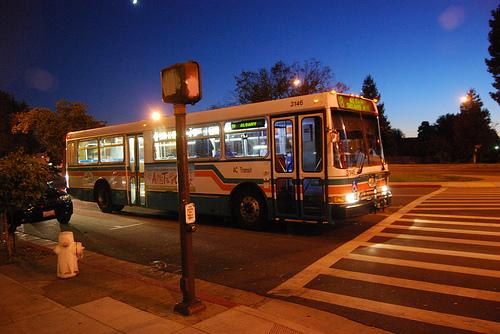Provide a brief summary of the key objects in the image and their interconnections. The central object is a large bus stopped at a crosswalk, featuring several windows, doors, and headlights, while a fire hydrant stands close by on the sidewalk. Describe the main focus in the image and any significant details. The image captures a long bus with various windows, doors, headlights, and a prominent windshield, paused at a crosswalk near a fire hydrant. Provide a concise caption of the central subject and its surroundings in the image. Bus stopped at crosswalk with multiple features, fire hydrant on sidewalk nearby. Write a short yet poetic description of the image. At the crosswalk's edge, a lengthy bus abides, windows glisten and doors align, while the stoic hydrant acquiesces nearby. Create a vivid description of the image using expressive language. A lengthy bus gracefully halts at a crosswalk, its numerous windows glistening, as a lone fire hydrant stands guard beside a tree on the sidewalk. Compose a description of the picture using informal language. This pic shows a long bus at a crosswalk with loads of windows, doors, and other stuff. There's a fire hydrant hangin' out on the sidewalk, too. Using conversational language, talk about the main subject and its environment in the image. You know, there's this long bus just chilling at a crosswalk, and it's got a bunch of windows, doors, and headlights. Oh, and there's a fire hydrant close by. Write a brief description of the primary object in the scene and its action. A long bus is stopped at a crosswalk, with multiple windows, doors, and headlights visible. Mention the most noticeable elements in the image and their specific locations. The image shows a bus with a clear windshield, a front and back door, numerous side windows, and a fire hydrant next to a tree on the sidewalk. Describe the image focusing on its size and dimensions. The scene shows an expansive bus measuring 327 by 327, with multiple 24 to 41 sized windows, a 58 sized door, and several smaller features, as well as a 29 by 29 fire hydrant. 